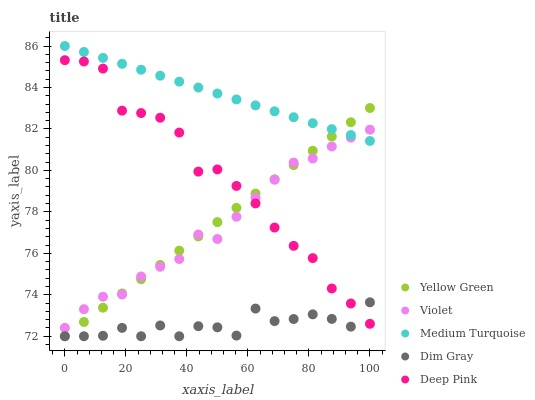Does Dim Gray have the minimum area under the curve?
Answer yes or no. Yes. Does Medium Turquoise have the maximum area under the curve?
Answer yes or no. Yes. Does Yellow Green have the minimum area under the curve?
Answer yes or no. No. Does Yellow Green have the maximum area under the curve?
Answer yes or no. No. Is Medium Turquoise the smoothest?
Answer yes or no. Yes. Is Dim Gray the roughest?
Answer yes or no. Yes. Is Yellow Green the smoothest?
Answer yes or no. No. Is Yellow Green the roughest?
Answer yes or no. No. Does Dim Gray have the lowest value?
Answer yes or no. Yes. Does Medium Turquoise have the lowest value?
Answer yes or no. No. Does Medium Turquoise have the highest value?
Answer yes or no. Yes. Does Yellow Green have the highest value?
Answer yes or no. No. Is Deep Pink less than Medium Turquoise?
Answer yes or no. Yes. Is Violet greater than Dim Gray?
Answer yes or no. Yes. Does Deep Pink intersect Dim Gray?
Answer yes or no. Yes. Is Deep Pink less than Dim Gray?
Answer yes or no. No. Is Deep Pink greater than Dim Gray?
Answer yes or no. No. Does Deep Pink intersect Medium Turquoise?
Answer yes or no. No. 